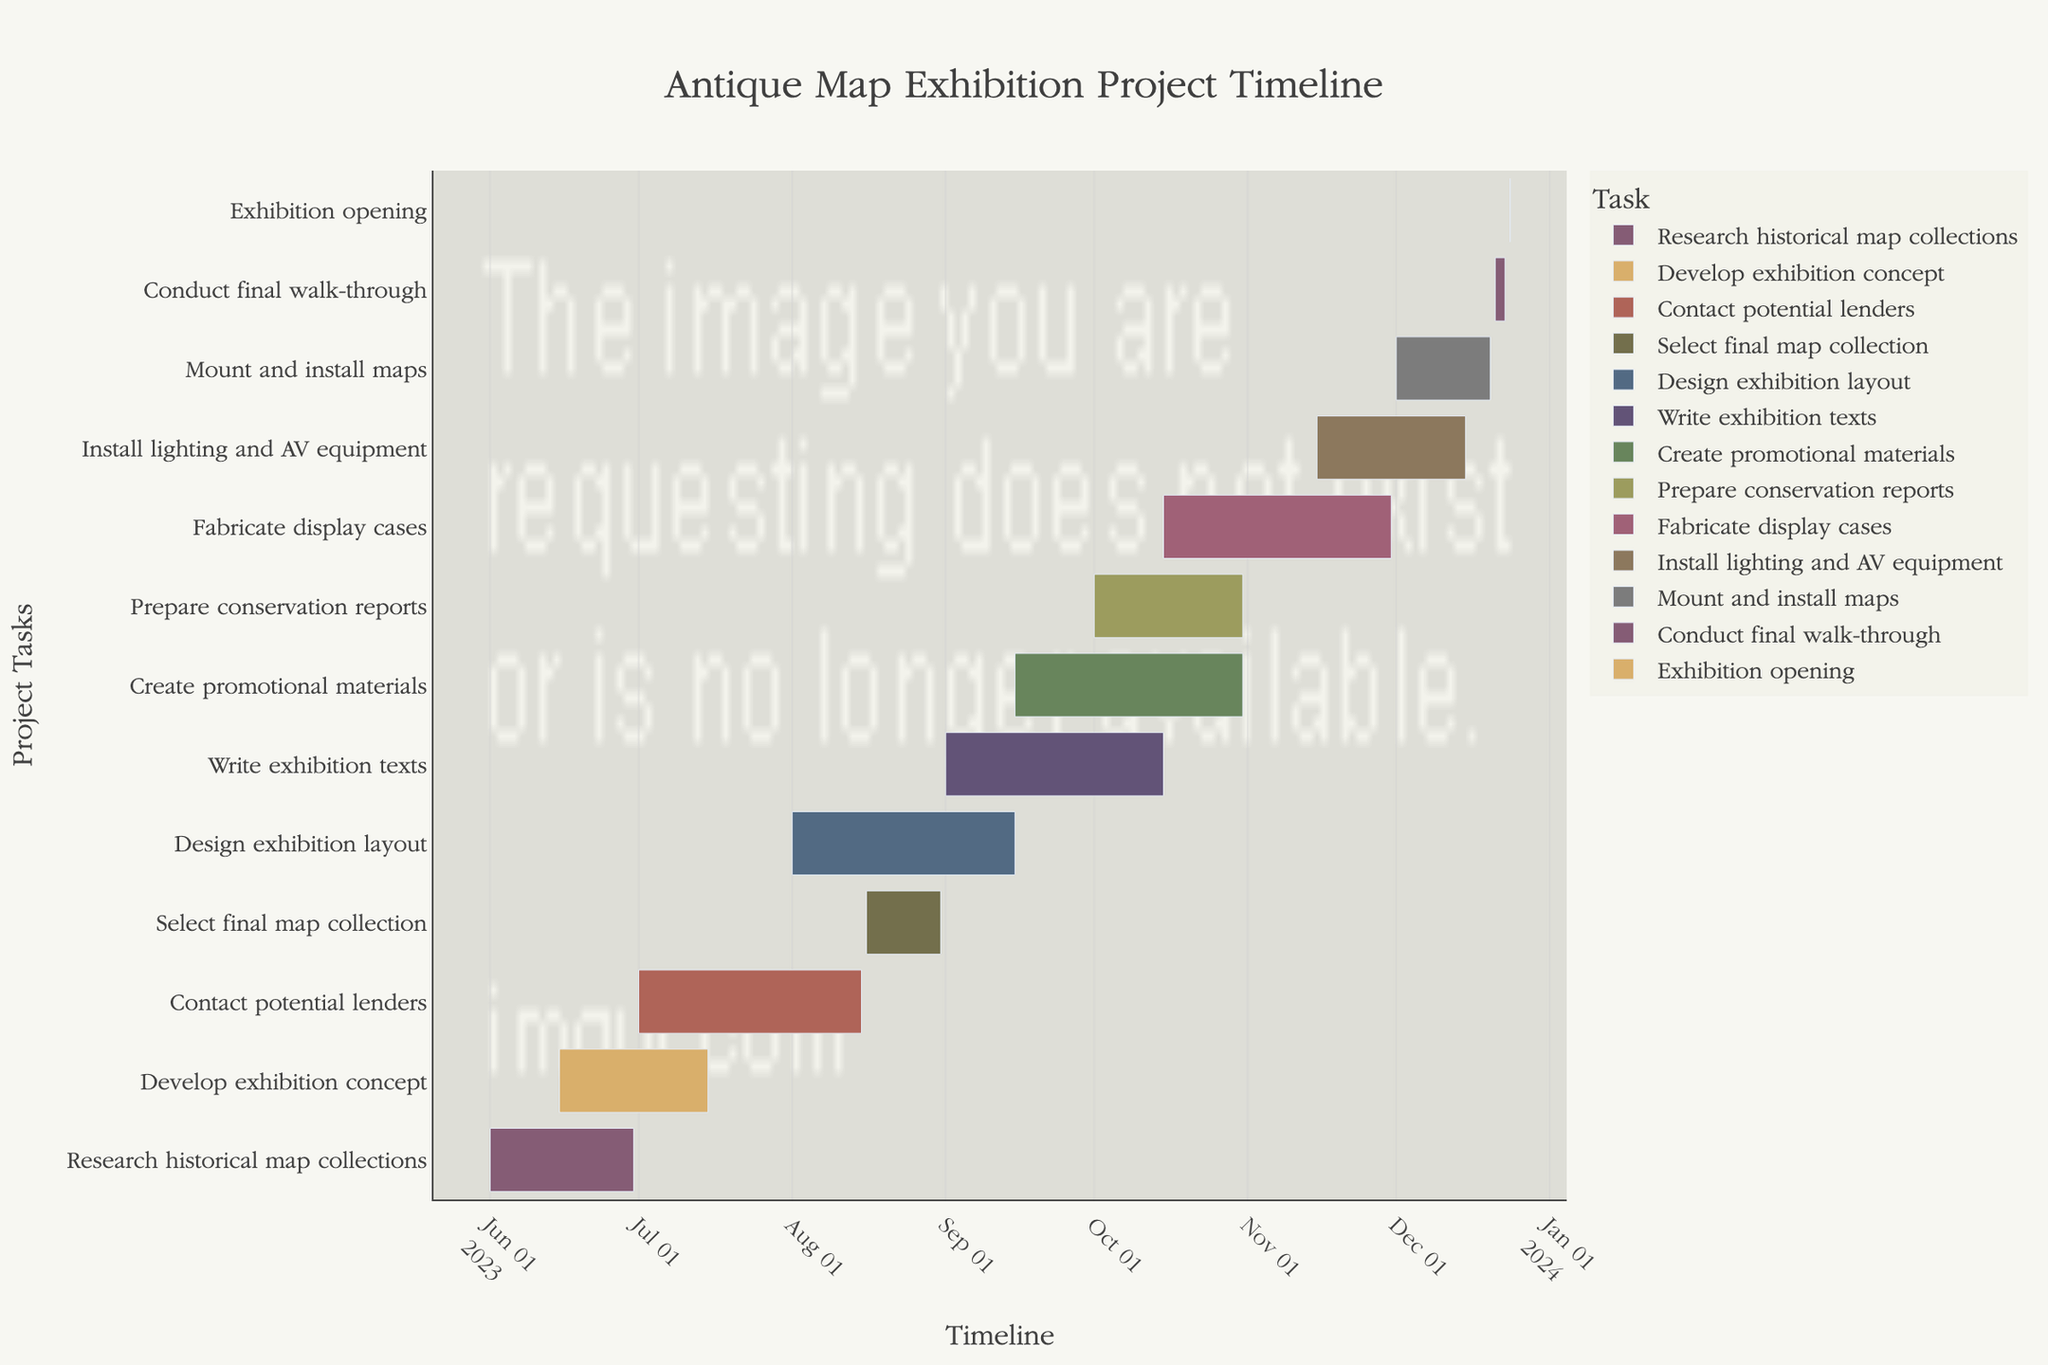What is the title of the project timeline? The title is displayed prominently at the top center of the chart. It reads "Antique Map Exhibition Project Timeline".
Answer: Antique Map Exhibition Project Timeline During which months does the "Research historical map collections" task occur? You can find the "Research historical map collections" task on the y-axis and follow its bar horizontally to see its start and end dates on the x-axis. It spans from June 1, 2023, to June 30, 2023.
Answer: June Which task has the shortest duration, and how many days does it last? By visually inspecting the length of the bars, "Exhibition opening" has the shortest duration. According to the hover info, it lasts for 1 day.
Answer: Exhibition opening, 1 day What is the total number of days between the start of "Develop exhibition concept" and its end? Locate the "Develop exhibition concept" task on the y-axis and note its start and end dates. It starts on June 15, 2023, and ends on July 15, 2023. By calculating the duration between these dates, you find it spans 31 days.
Answer: 31 days Which two tasks overlap during September 2023? Inspect the bars that span across the September period, looking for overlapping dates. "Design exhibition layout" and "Write exhibition texts" both overlap during September 2023.
Answer: Design exhibition layout and Write exhibition texts When does the “Mount and install maps” task begin and end? Look for the "Mount and install maps" task on the y-axis and follow its bar horizontally to see its start and end dates on the x-axis. It begins on December 1, 2023, and ends on December 20, 2023.
Answer: December 1, 2023, to December 20, 2023 Which task takes the longest time to complete? By visually inspecting the length of the bars, "Create promotional materials" has one of the longest bars. The hover info shows it lasts 47 days, confirming it is the longest task.
Answer: Create promotional materials How many tasks are completed before October 2023? Count the bars that end before October 2023. "Research historical map collections", "Develop exhibition concept", "Contact potential lenders", "Select final map collection", and "Design exhibition layout" all end before October 2023, totaling 5 tasks.
Answer: 5 tasks Which task directly precedes the "Conduct final walk-through" task? Locate the "Conduct final walk-through" task on the y-axis and find the task immediately above it. "Mount and install maps" is immediately before it on the chart.
Answer: Mount and install maps What is the duration of the “Prepare conservation reports” task in days? Look up the duration directly in the hover info for the "Prepare conservation reports" task. It is mentioned as 31 days in the chart.
Answer: 31 days 